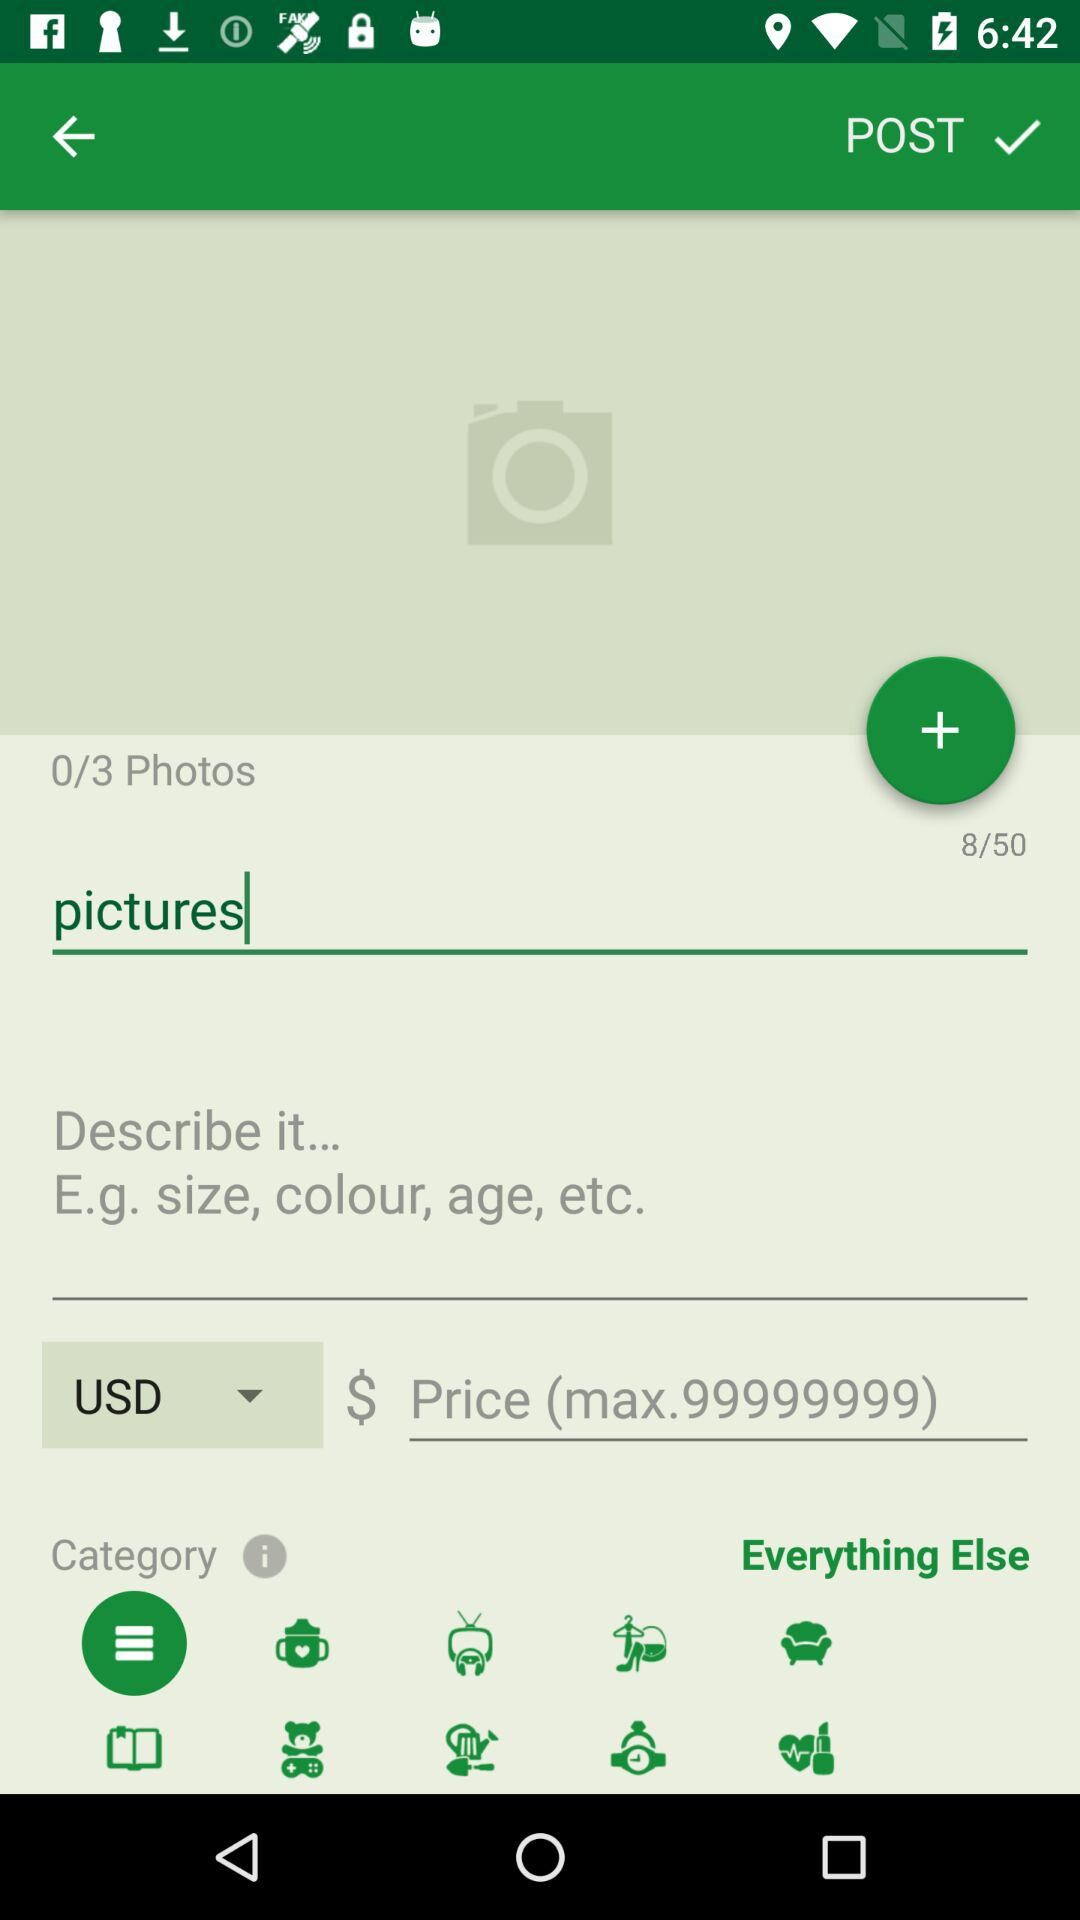What is the maximum price that can be entered? The maximum price that can be entered is $99999999. 